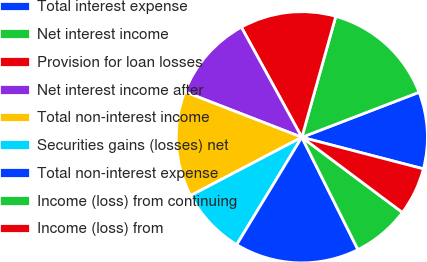Convert chart to OTSL. <chart><loc_0><loc_0><loc_500><loc_500><pie_chart><fcel>Total interest expense<fcel>Net interest income<fcel>Provision for loan losses<fcel>Net interest income after<fcel>Total non-interest income<fcel>Securities gains (losses) net<fcel>Total non-interest expense<fcel>Income (loss) from continuing<fcel>Income (loss) from<nl><fcel>9.88%<fcel>14.81%<fcel>12.35%<fcel>11.11%<fcel>13.58%<fcel>8.64%<fcel>16.05%<fcel>7.41%<fcel>6.17%<nl></chart> 